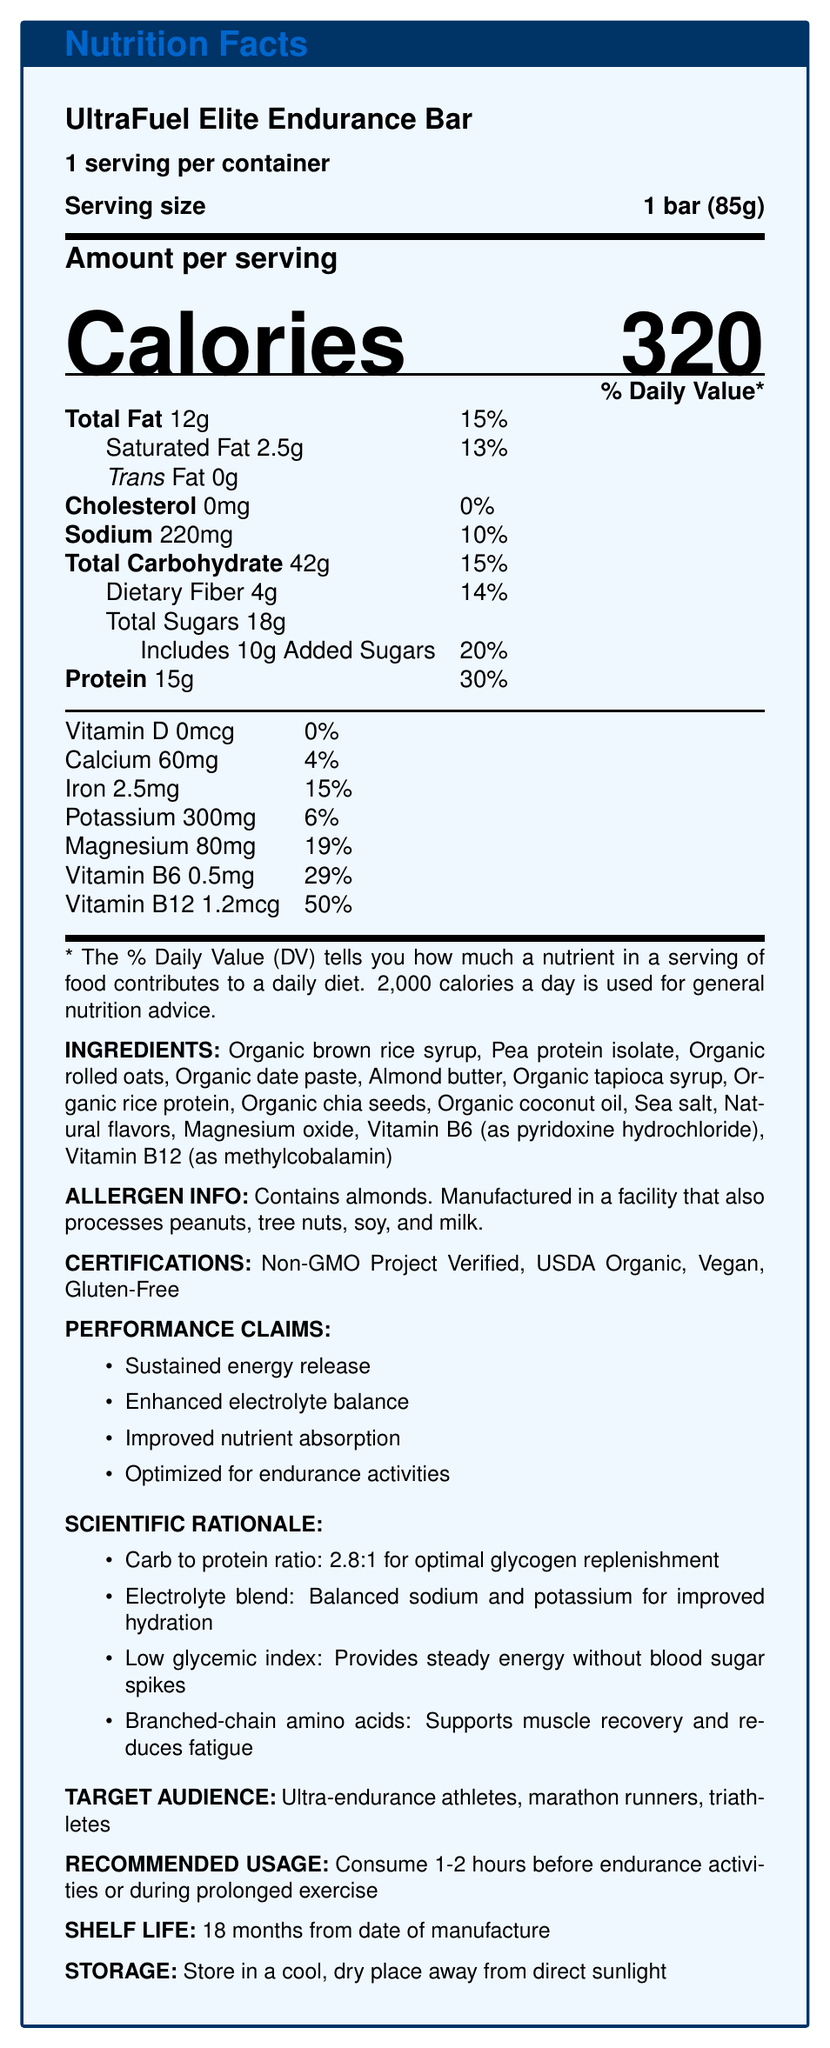What is the serving size of the UltraFuel Elite Endurance Bar? The serving size is mentioned as "1 bar (85g)" under the main title.
Answer: 1 bar (85g) How many calories are in one serving of the UltraFuel Elite Endurance Bar? The document lists "320" calories under the bold title "Calories".
Answer: 320 What is the percentage of the daily value of protein in the UltraFuel Elite Endurance Bar? The protein content is displayed as "15g" with a percentage daily value of "30%".
Answer: 30% What certifications does the UltraFuel Elite Endurance Bar have? Under the "CERTIFICATIONS" section, the listed certifications are "Non-GMO Project Verified", "USDA Organic", "Vegan", and "Gluten-Free".
Answer: Non-GMO Project Verified, USDA Organic, Vegan, Gluten-Free What is the performance claim associated with electrolyte balance? "Enhanced electrolyte balance" is one of the performance claims listed.
Answer: Enhanced electrolyte balance What is the source of Vitamin B6 in the UltraFuel Elite Endurance Bar's ingredients? Vitamin B6 is listed as "Vitamin B6 (as pyridoxine hydrochloride)" in the ingredients.
Answer: Pyridoxine hydrochloride Does the UltraFuel Elite Endurance Bar contain any trans fat? The document specifies "Trans Fat 0g".
Answer: No How much added sugar is present in the UltraFuel Elite Endurance Bar? Added sugars are listed as "Includes 10g Added Sugars".
Answer: 10g What is the primary target audience for the UltraFuel Elite Endurance Bar? The target audience listed is "Ultra-endurance athletes, marathon runners, triathletes".
Answer: Ultra-endurance athletes, marathon runners, triathletes How long is the shelf life of the UltraFuel Elite Endurance Bar? Under the "SHELF LIFE" section, the given shelf life is "18 months from date of manufacture".
Answer: 18 months from date of manufacture Which of the following minerals has the highest percentage daily value in the UltraFuel Elite Endurance Bar?
A. Calcium
B. Iron
C. Magnesium
D. Potassium While Calcium has 4%, Iron 15%, Potassium 6%, Magnesium has 19% of the daily value.
Answer: C. Magnesium How does the UltraFuel Elite Endurance Bar help in muscle recovery?
A. High fiber content
B. Balanced electrolyte blend
C. Branched-chain amino acids
D. Low glycemic index The document mentions "Branched-chain amino acids: Supports muscle recovery and reduces fatigue" under scientific rationale.
Answer: C. Branched-chain amino acids Is the UltraFuel Elite Endurance Bar gluten-free? It is listed in the CERTIFICATIONS section as "Gluten-Free".
Answer: Yes Summarize the UltraFuel Elite Endurance Bar's nutrition information and benefits. This summary covers both the nutritional content and performance claims emphasized in the document.
Answer: The UltraFuel Elite Endurance Bar is a high-performance energy bar designed for endurance athletes. It contains 320 calories per serving, 12g total fat, 42g carbohydrates, and 15g protein. Key nutrients include iron, magnesium, and vitamins B6 and B12. The bar is certified Non-GMO, USDA Organic, Vegan, and Gluten-Free. Performance benefits include sustained energy release, enhanced electrolyte balance, and improved nutrient absorption, with a recommendation to consume 1-2 hours before or during prolonged exercise. What is the manufacturing facility for the UltraFuel Elite Endurance Bar? The document does not provide specific information about the manufacturing facility location.
Answer: Not enough information 